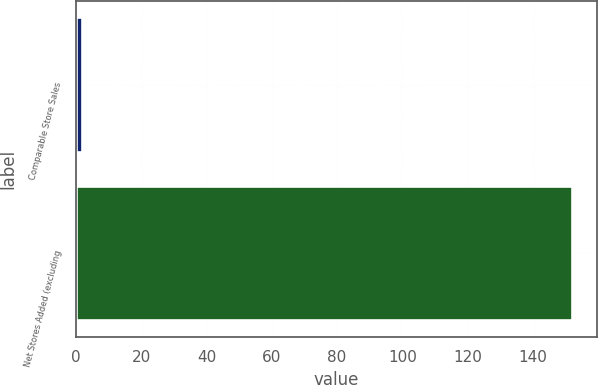Convert chart. <chart><loc_0><loc_0><loc_500><loc_500><bar_chart><fcel>Comparable Store Sales<fcel>Net Stores Added (excluding<nl><fcel>1.7<fcel>152<nl></chart> 